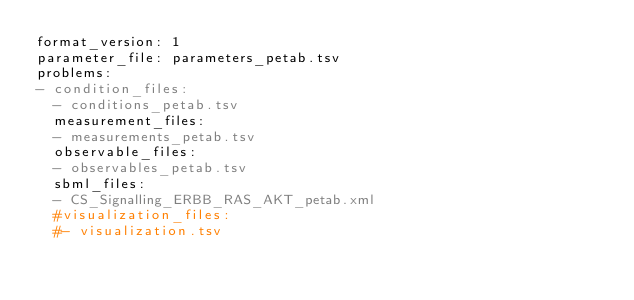Convert code to text. <code><loc_0><loc_0><loc_500><loc_500><_YAML_>format_version: 1
parameter_file: parameters_petab.tsv
problems:
- condition_files:
  - conditions_petab.tsv
  measurement_files:
  - measurements_petab.tsv
  observable_files:
  - observables_petab.tsv
  sbml_files:
  - CS_Signalling_ERBB_RAS_AKT_petab.xml
  #visualization_files:
  #- visualization.tsv
</code> 